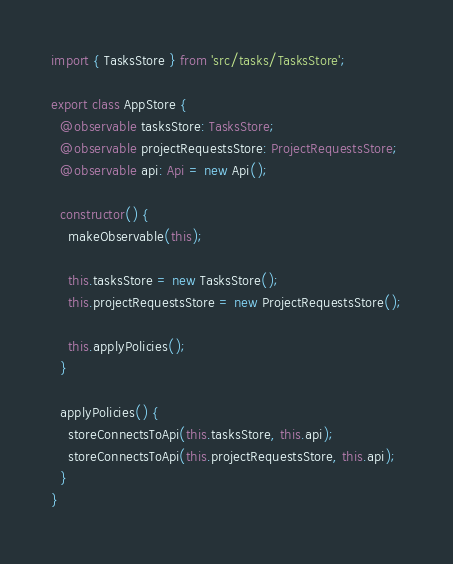<code> <loc_0><loc_0><loc_500><loc_500><_TypeScript_>import { TasksStore } from 'src/tasks/TasksStore';

export class AppStore {
  @observable tasksStore: TasksStore;
  @observable projectRequestsStore: ProjectRequestsStore;
  @observable api: Api = new Api();

  constructor() {
    makeObservable(this);

    this.tasksStore = new TasksStore();
    this.projectRequestsStore = new ProjectRequestsStore();

    this.applyPolicies();
  }

  applyPolicies() {
    storeConnectsToApi(this.tasksStore, this.api);
    storeConnectsToApi(this.projectRequestsStore, this.api);
  }
}
</code> 